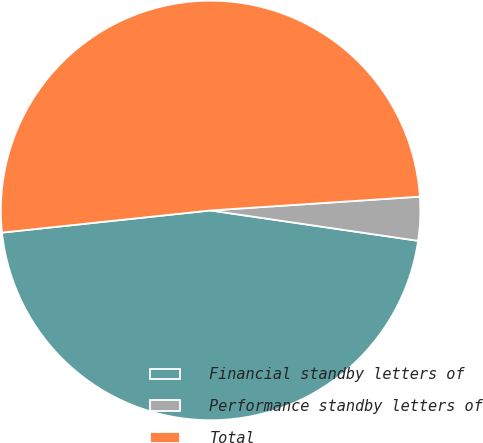Convert chart. <chart><loc_0><loc_0><loc_500><loc_500><pie_chart><fcel>Financial standby letters of<fcel>Performance standby letters of<fcel>Total<nl><fcel>46.0%<fcel>3.36%<fcel>50.63%<nl></chart> 